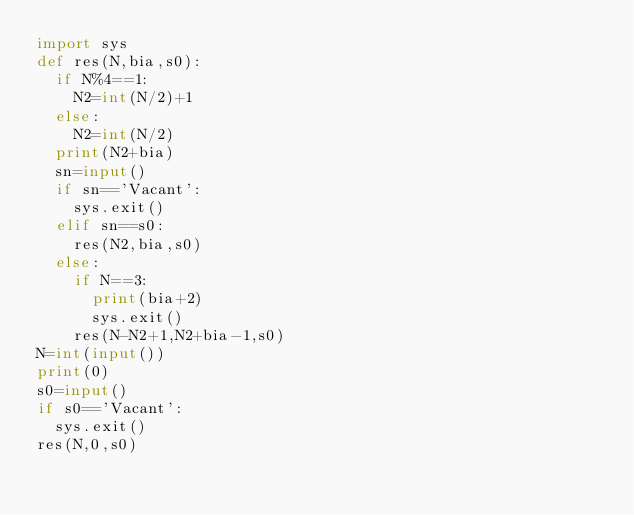Convert code to text. <code><loc_0><loc_0><loc_500><loc_500><_Python_>import sys
def res(N,bia,s0):
  if N%4==1:
    N2=int(N/2)+1
  else:
    N2=int(N/2)
  print(N2+bia)
  sn=input()
  if sn=='Vacant':
    sys.exit()
  elif sn==s0:
    res(N2,bia,s0)
  else:
    if N==3:
      print(bia+2)
      sys.exit()
    res(N-N2+1,N2+bia-1,s0)
N=int(input())
print(0)
s0=input()
if s0=='Vacant':
  sys.exit()
res(N,0,s0)</code> 